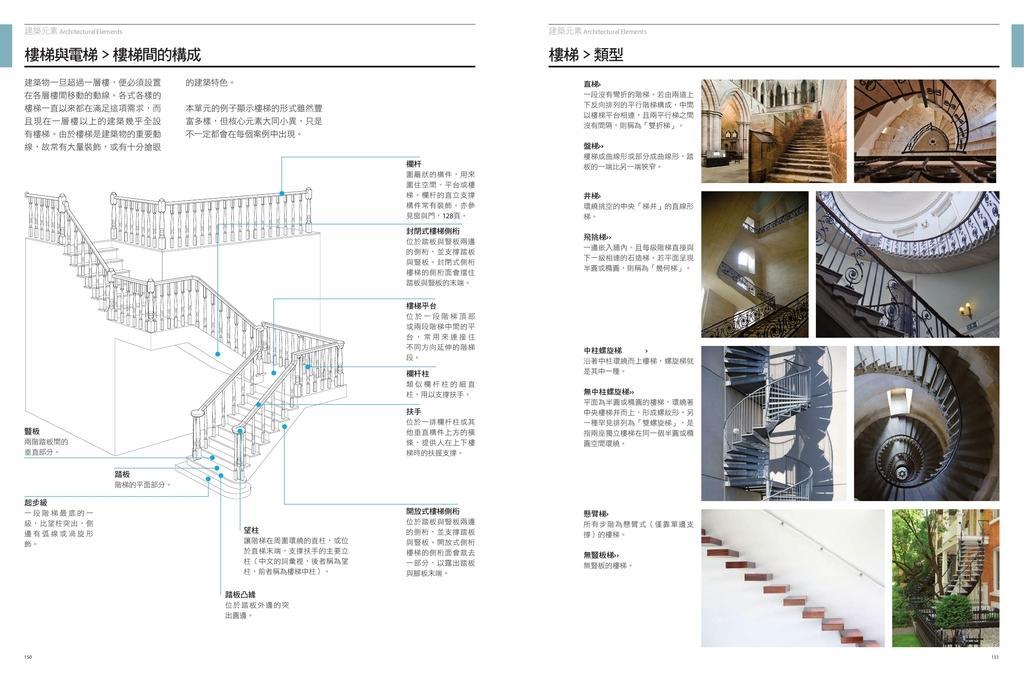Could you give a brief overview of what you see in this image? In this image we can see a layout of a staircase on the left side with labels. Also something is written on the image. On the right side we can see images of staircase with railings. In the right bottom corner there is an image with trees and building. 